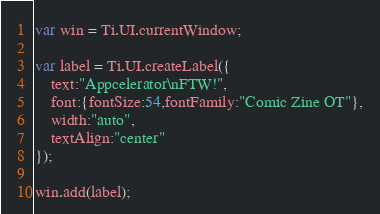Convert code to text. <code><loc_0><loc_0><loc_500><loc_500><_JavaScript_>var win = Ti.UI.currentWindow;

var label = Ti.UI.createLabel({
	text:"Appcelerator\nFTW!",
	font:{fontSize:54,fontFamily:"Comic Zine OT"},
	width:"auto",
	textAlign:"center"
});

win.add(label);</code> 